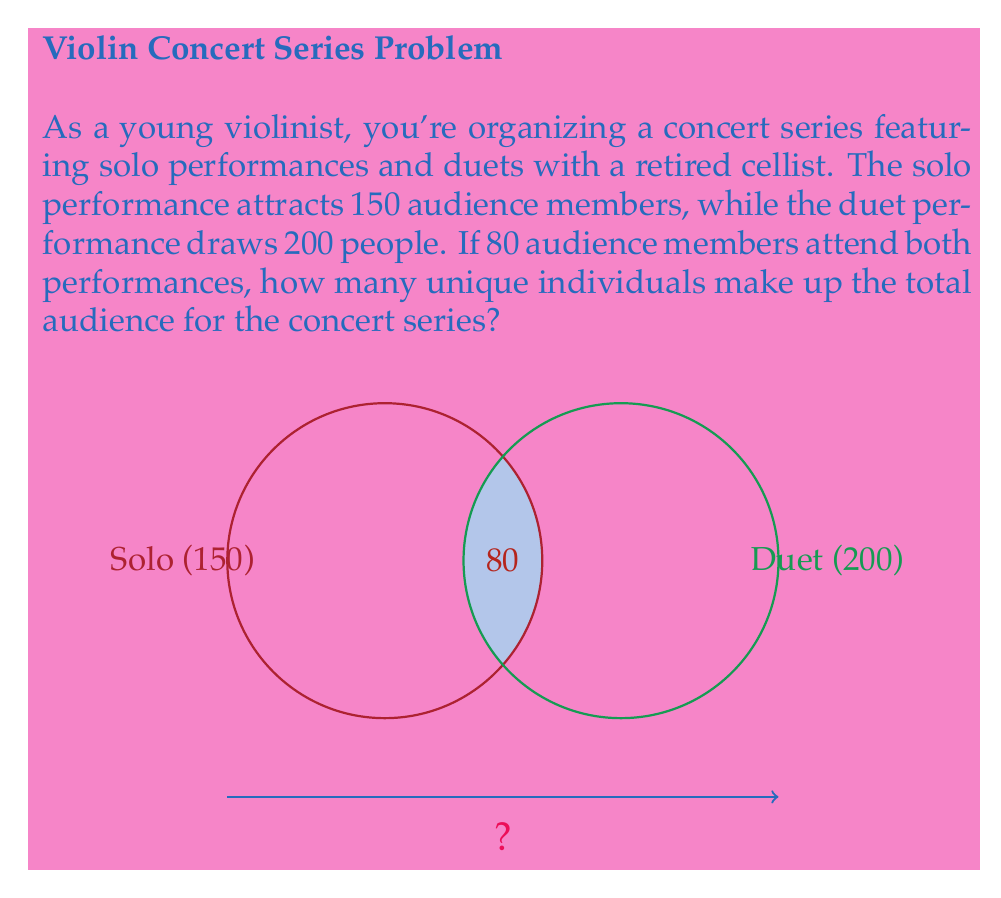Could you help me with this problem? Let's approach this step-by-step using set theory:

1) Let $S$ be the set of audience members attending the solo performance, and $D$ be the set of audience members attending the duet performance.

2) We're given:
   $|S| = 150$ (cardinality of set S)
   $|D| = 200$ (cardinality of set D)
   $|S \cap D| = 80$ (cardinality of the intersection of S and D)

3) We need to find $|S \cup D|$ (the cardinality of the union of S and D).

4) We can use the principle of inclusion-exclusion:

   $|S \cup D| = |S| + |D| - |S \cap D|$

5) Substituting the values:

   $|S \cup D| = 150 + 200 - 80$

6) Calculating:

   $|S \cup D| = 350 - 80 = 270$

Therefore, the total number of unique audience members for the concert series is 270.
Answer: 270 